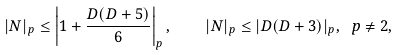<formula> <loc_0><loc_0><loc_500><loc_500>| N | _ { p } \leq \left | 1 + \frac { D ( D + 5 ) } { 6 } \right | _ { p } , \quad | N | _ { p } \leq | D ( D + 3 ) | _ { p } , \ p \neq 2 ,</formula> 